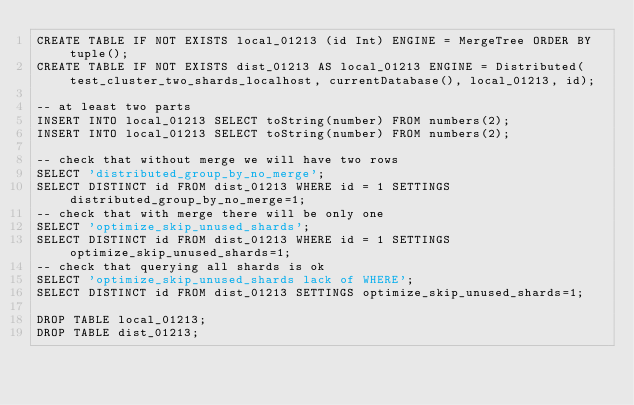<code> <loc_0><loc_0><loc_500><loc_500><_SQL_>CREATE TABLE IF NOT EXISTS local_01213 (id Int) ENGINE = MergeTree ORDER BY tuple();
CREATE TABLE IF NOT EXISTS dist_01213 AS local_01213 ENGINE = Distributed(test_cluster_two_shards_localhost, currentDatabase(), local_01213, id);

-- at least two parts
INSERT INTO local_01213 SELECT toString(number) FROM numbers(2);
INSERT INTO local_01213 SELECT toString(number) FROM numbers(2);

-- check that without merge we will have two rows
SELECT 'distributed_group_by_no_merge';
SELECT DISTINCT id FROM dist_01213 WHERE id = 1 SETTINGS distributed_group_by_no_merge=1;
-- check that with merge there will be only one
SELECT 'optimize_skip_unused_shards';
SELECT DISTINCT id FROM dist_01213 WHERE id = 1 SETTINGS optimize_skip_unused_shards=1;
-- check that querying all shards is ok
SELECT 'optimize_skip_unused_shards lack of WHERE';
SELECT DISTINCT id FROM dist_01213 SETTINGS optimize_skip_unused_shards=1;

DROP TABLE local_01213;
DROP TABLE dist_01213;
</code> 